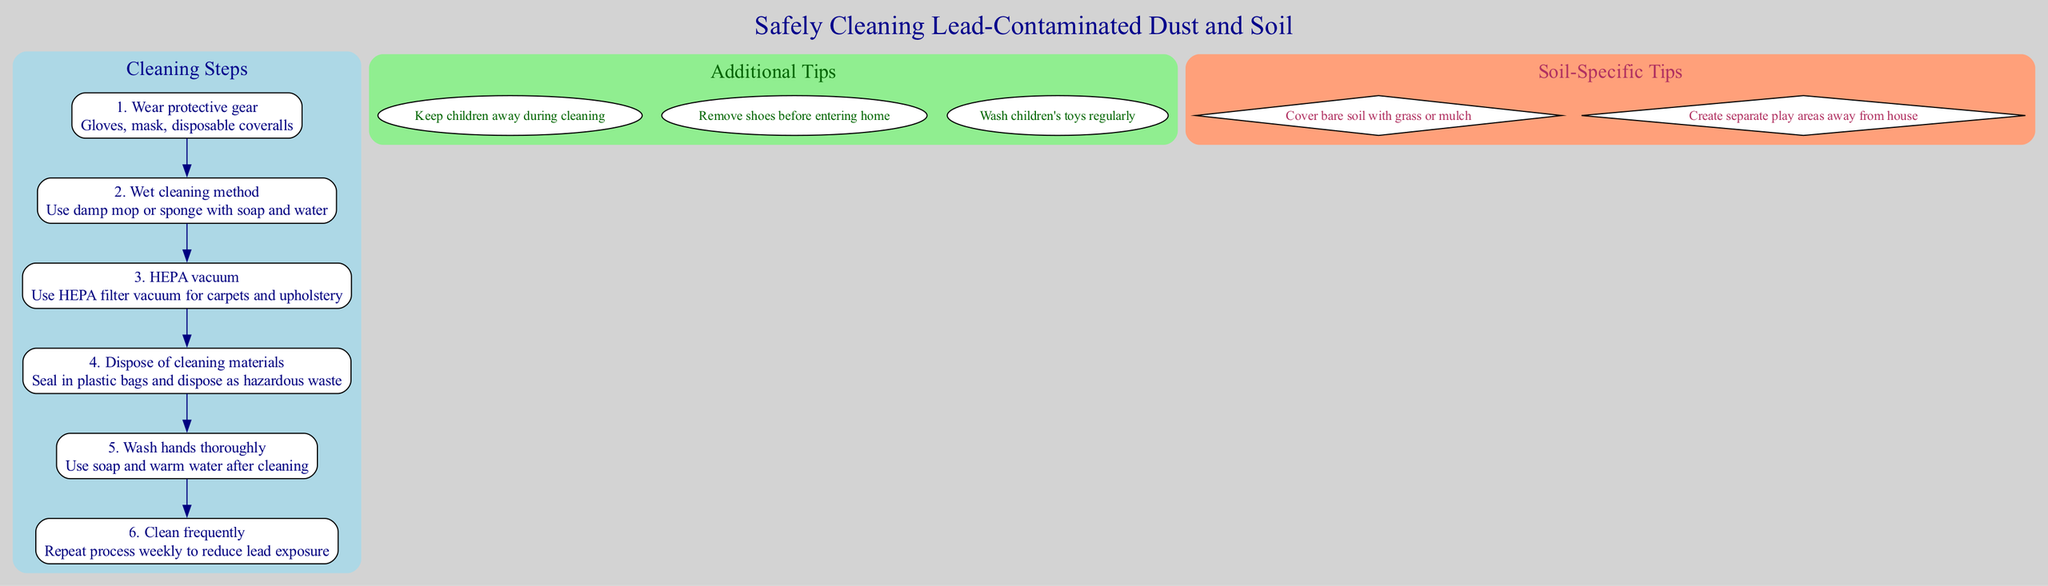What are the steps involved in cleaning lead-contaminated dust and soil? The diagram lists six specific steps for cleaning lead-contaminated dust and soil, which include wearing protective gear, using a wet cleaning method, using a HEPA vacuum, disposing of cleaning materials, washing hands thoroughly, and cleaning frequently.
Answer: six What protective gear is recommended? The diagram specifies wearing gloves, a mask, and disposable coveralls as protective gear during cleaning to prevent lead exposure.
Answer: gloves, mask, disposable coveralls How often should the cleaning process be repeated? The infographic advises repeating the cleaning process weekly to effectively reduce lead exposure in the home environment.
Answer: weekly What is an appropriate method for cleaning surfaces? According to the diagram, the wet cleaning method involves using a damp mop or sponge with soap and water for safe and effective cleaning of surfaces.
Answer: damp mop or sponge with soap and water What should you do with the cleaning materials after use? The diagram indicates that used cleaning materials should be sealed in plastic bags and disposed of as hazardous waste to prevent lead contamination.
Answer: seal in plastic bags and dispose as hazardous waste Which additional tip involves removing footwear? The infographic includes a tip to remove shoes before entering the home, which helps reduce lead contamination brought in from outside.
Answer: remove shoes before entering home What is a soil-specific tip mentioned in the diagram? One soil-specific tip provided in the diagram recommends covering bare soil with grass or mulch, which helps to minimize lead exposure in outdoor play areas.
Answer: cover bare soil with grass or mulch Which area should be away from the house for safe play? The diagram suggests creating separate play areas away from the house as a measure to reduce children's lead exposure from contaminated soil.
Answer: create separate play areas away from house 